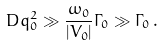Convert formula to latex. <formula><loc_0><loc_0><loc_500><loc_500>D q _ { 0 } ^ { 2 } \gg \frac { \omega _ { 0 } } { | V _ { 0 } | } \Gamma _ { 0 } \gg \Gamma _ { 0 } \, .</formula> 